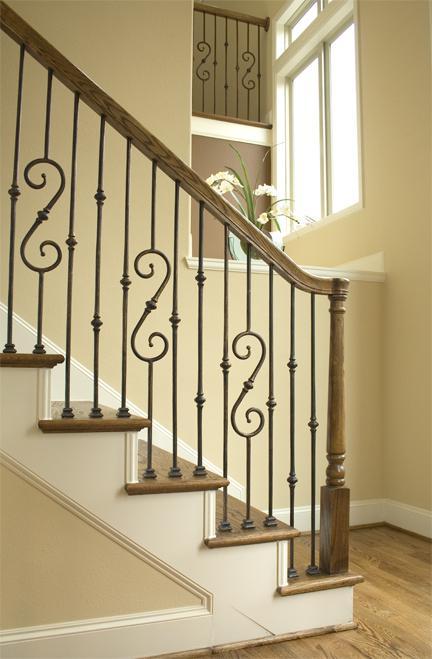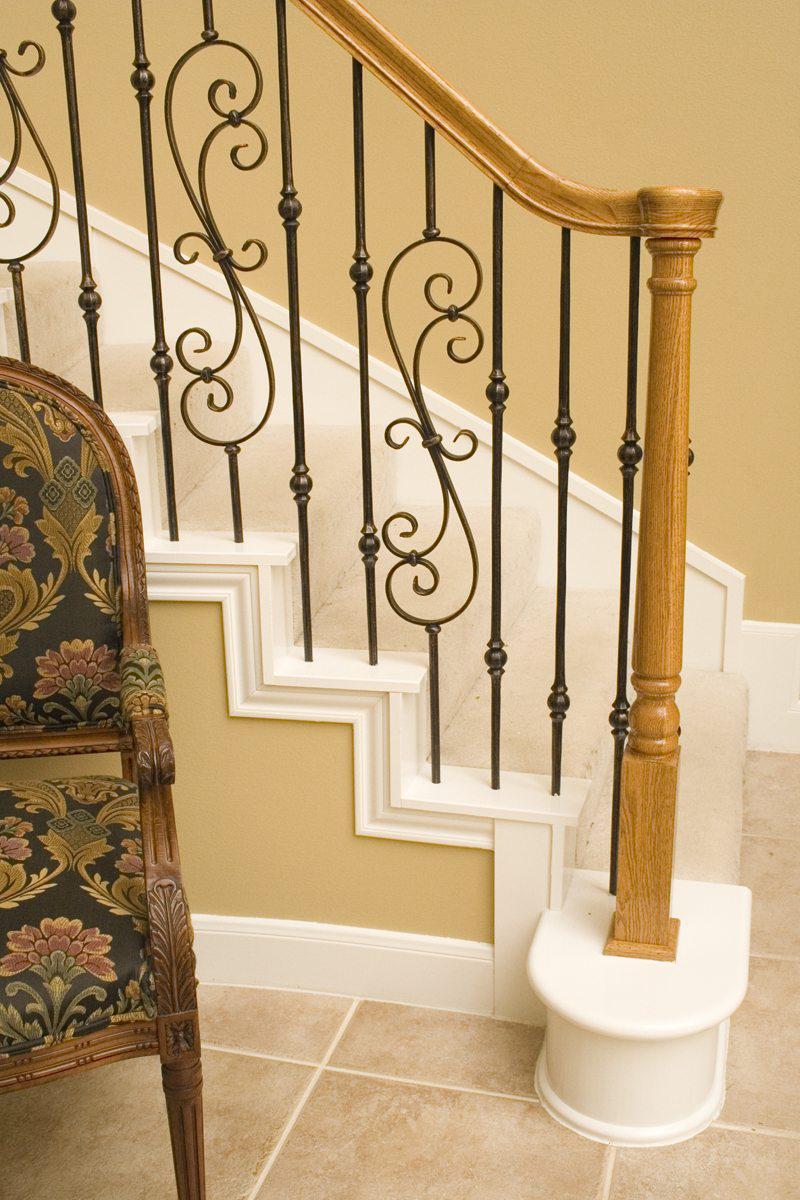The first image is the image on the left, the second image is the image on the right. For the images displayed, is the sentence "The left and right image contains the same number of staircase with wooden and metal S shaped rails." factually correct? Answer yes or no. Yes. 